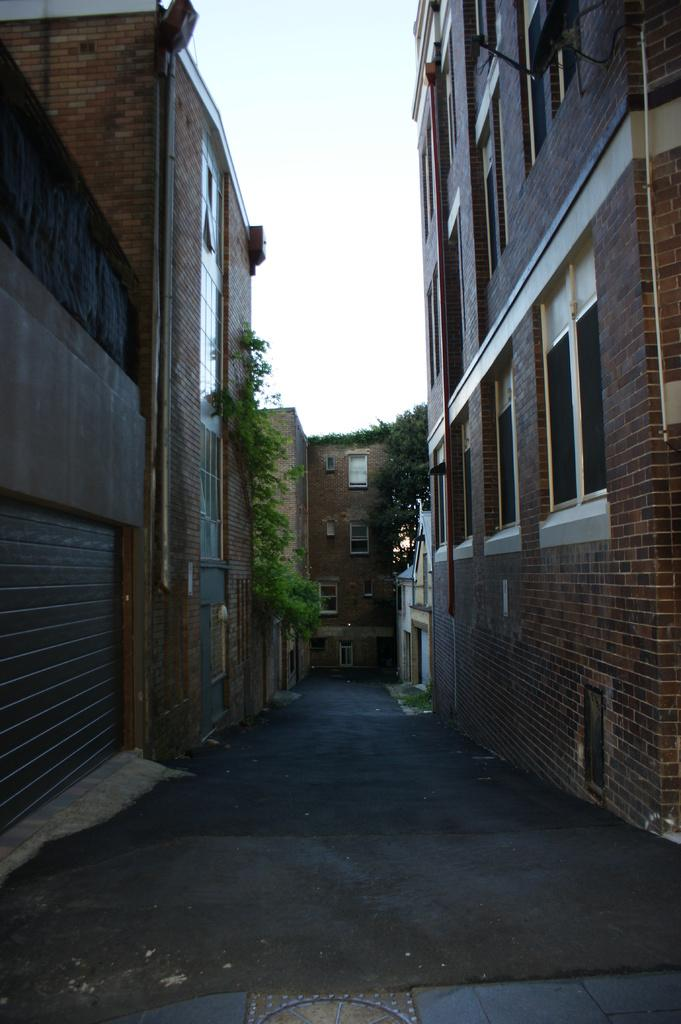What type of structures can be seen in the image? There are buildings in the image. What type of vegetation is present in the image? Creepers are present in the image. What feature can be seen on the buildings in the image? There are windows visible in the image. What is visible in the background of the image? The sky is visible in the image. How much honey is being collected by the bees in the image? There are no bees or honey present in the image; it features buildings and creepers. 